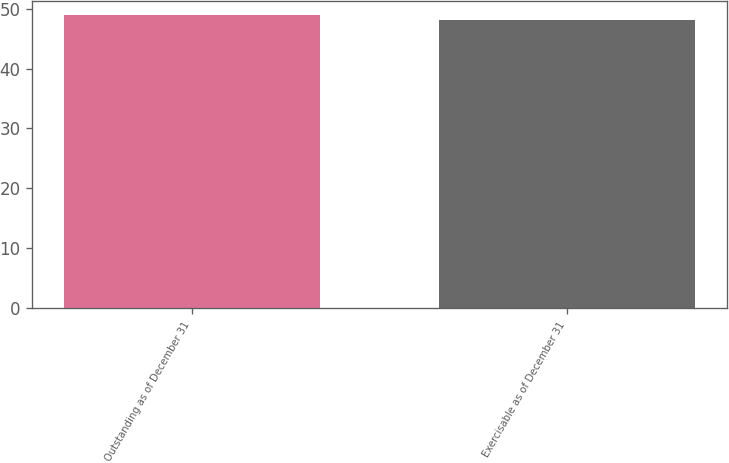Convert chart. <chart><loc_0><loc_0><loc_500><loc_500><bar_chart><fcel>Outstanding as of December 31<fcel>Exercisable as of December 31<nl><fcel>48.88<fcel>48.16<nl></chart> 